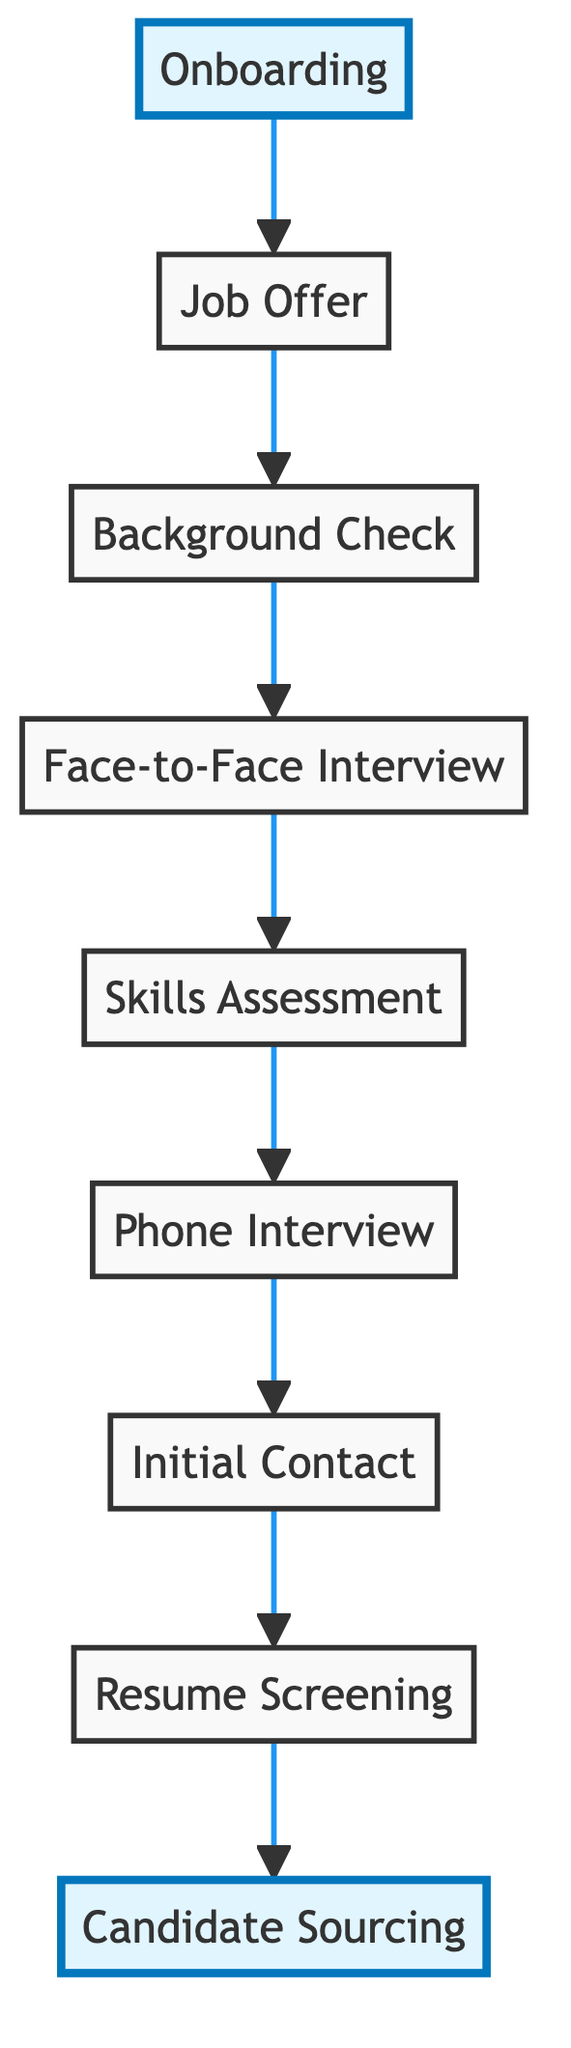What is the first step in the hiring pipeline? The diagram shows that the first step in the hiring pipeline is "Candidate Sourcing," which is at the bottom of the flow chart.
Answer: Candidate Sourcing How many steps are there in the hiring pipeline? By counting the nodes in the diagram, we find there are nine distinct steps in the hiring pipeline represented in the flow chart.
Answer: Nine What comes after the Phone Interview? According to the flow directions in the diagram, the step that directly follows the Phone Interview is the Skills Assessment.
Answer: Skills Assessment Which step comes before the Job Offer? From the diagram, the step immediately preceding the Job Offer is the Background Check, as shown by the directional flow.
Answer: Background Check Are there any highlighted steps in the diagram? Yes, the steps "Candidate Sourcing" and "Onboarding" are highlighted within the diagram to indicate their significance in the overall process.
Answer: Yes After completing Onboarding, what is the last action in the hiring process? The flow indicates that the last action in the hiring process is the Job Offer, which is the final step before Onboarding, but as a terminal step, Onboarding is also a final node.
Answer: Onboarding What type of relationships are shown between the steps? The diagram illustrates a sequential relationship indicating a prescribed order of actions in the hiring pipeline, primarily data flow from one action to the next.
Answer: Sequential If a candidate is successfully onboarded, which step did they complete before that? The onboarding step follows the Job Offer, which indicates that the candidates would have successfully completed the Job Offer before onboarding.
Answer: Job Offer Which two steps are connected directly by a single arrow? Direct connections can be seen between multiple pairs, but a specific example is the connection from Background Check to Job Offer, indicating a direct transition.
Answer: Background Check and Job Offer 